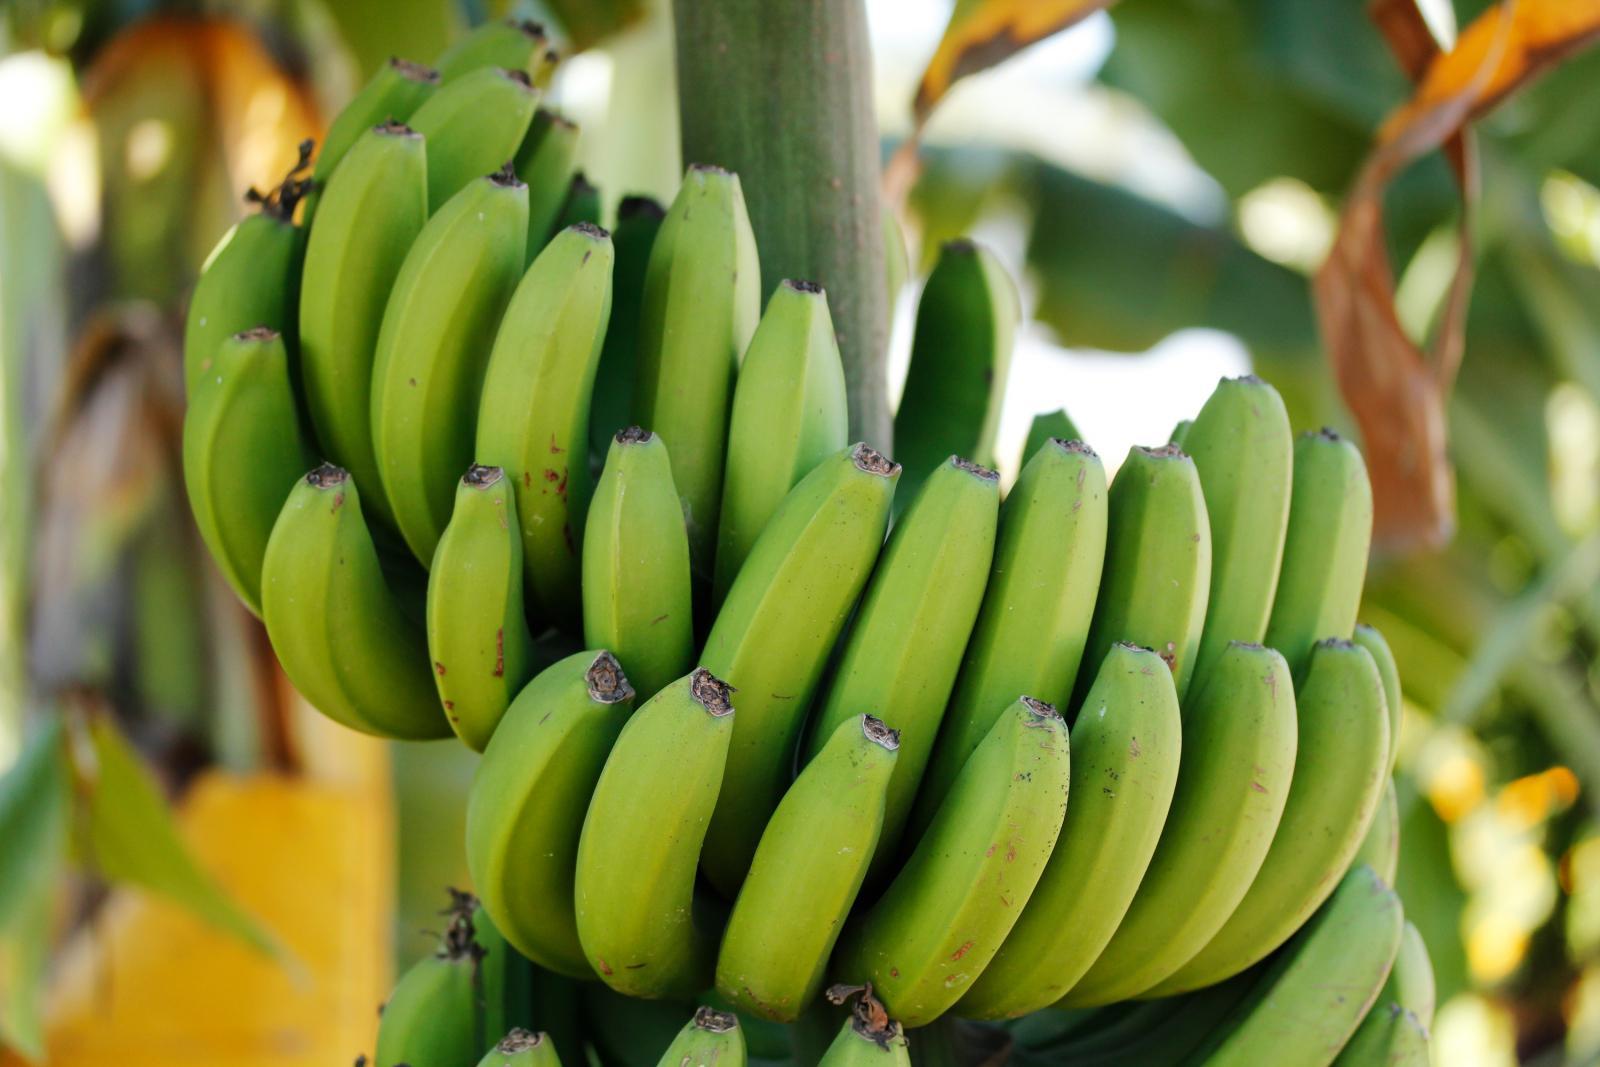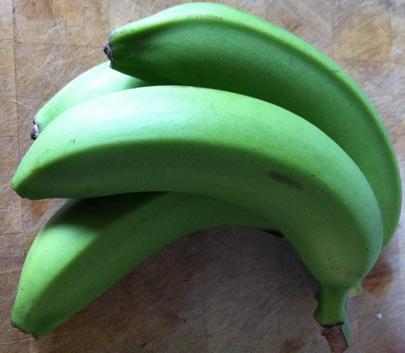The first image is the image on the left, the second image is the image on the right. Assess this claim about the two images: "An image contains no more than three bananas, and the bananas have some brownish patches.". Correct or not? Answer yes or no. No. The first image is the image on the left, the second image is the image on the right. Evaluate the accuracy of this statement regarding the images: "One image contains three or less plantains, the other contains more than six bananas.". Is it true? Answer yes or no. No. 